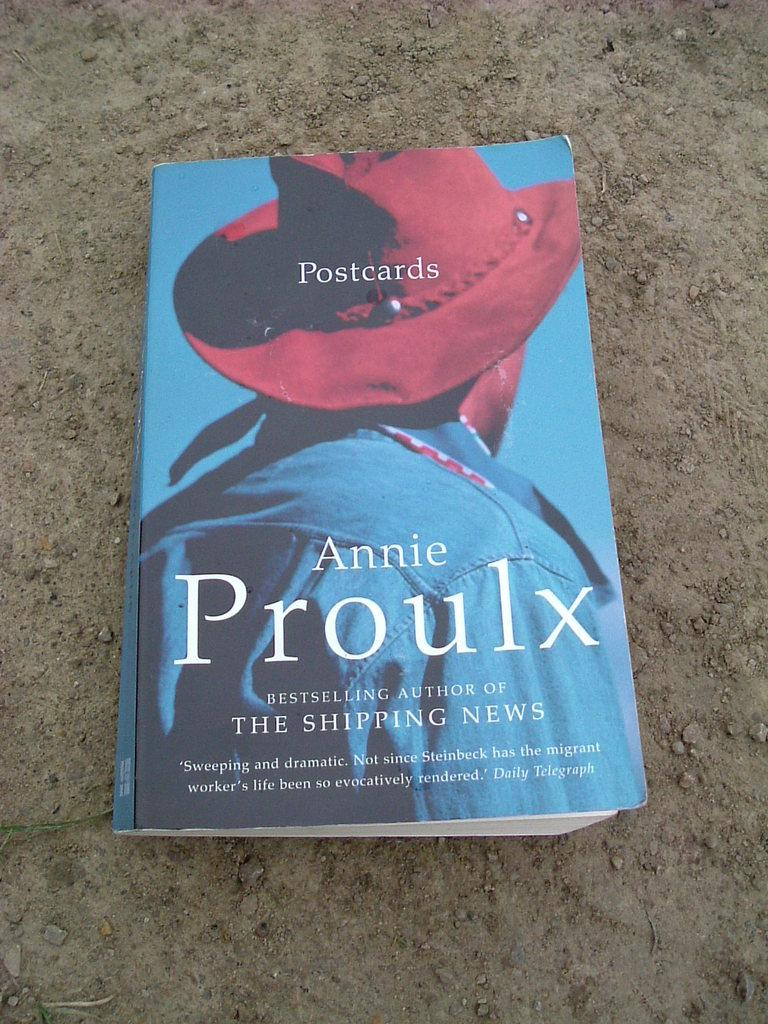<image>
Share a concise interpretation of the image provided. A book sitting on a floor called Postcards by Annie Proulx. 